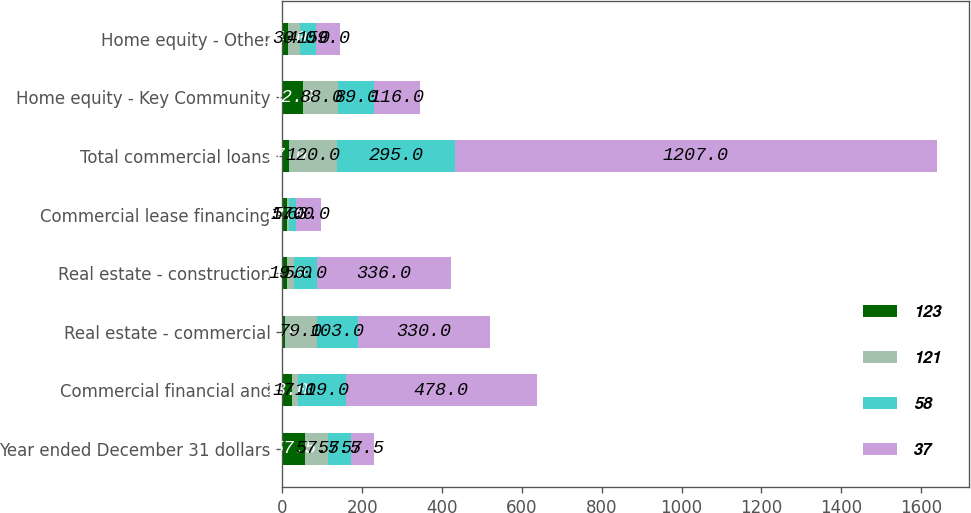Convert chart to OTSL. <chart><loc_0><loc_0><loc_500><loc_500><stacked_bar_chart><ecel><fcel>Year ended December 31 dollars<fcel>Commercial financial and<fcel>Real estate - commercial<fcel>Real estate - construction<fcel>Commercial lease financing<fcel>Total commercial loans<fcel>Home equity - Key Community<fcel>Home equity - Other<nl><fcel>123<fcel>57.5<fcel>23<fcel>7<fcel>11<fcel>12<fcel>17<fcel>52<fcel>14<nl><fcel>121<fcel>57.5<fcel>17<fcel>79<fcel>19<fcel>5<fcel>120<fcel>88<fcel>30<nl><fcel>58<fcel>57.5<fcel>119<fcel>103<fcel>56<fcel>17<fcel>295<fcel>89<fcel>41<nl><fcel>37<fcel>57.5<fcel>478<fcel>330<fcel>336<fcel>63<fcel>1207<fcel>116<fcel>59<nl></chart> 